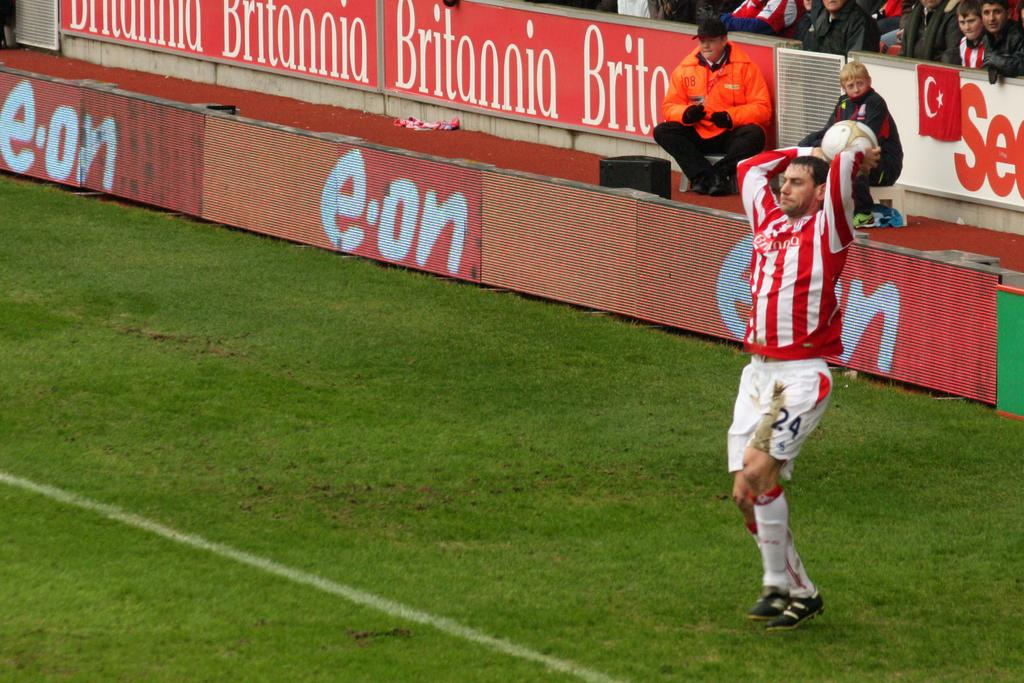What is the main subject of the image? The main subject of the image is a man. What is the man doing in the image? The man is standing and holding a ball in his hand. Are there any other people in the image? Yes, there are people watching the man in the image. What is the ground made of in the image? The ground is filled with grass. What type of cast can be seen on the man's arm in the image? There is no cast visible on the man's arm in the image. What shape is the mountain in the image? There is no mountain present in the image. 